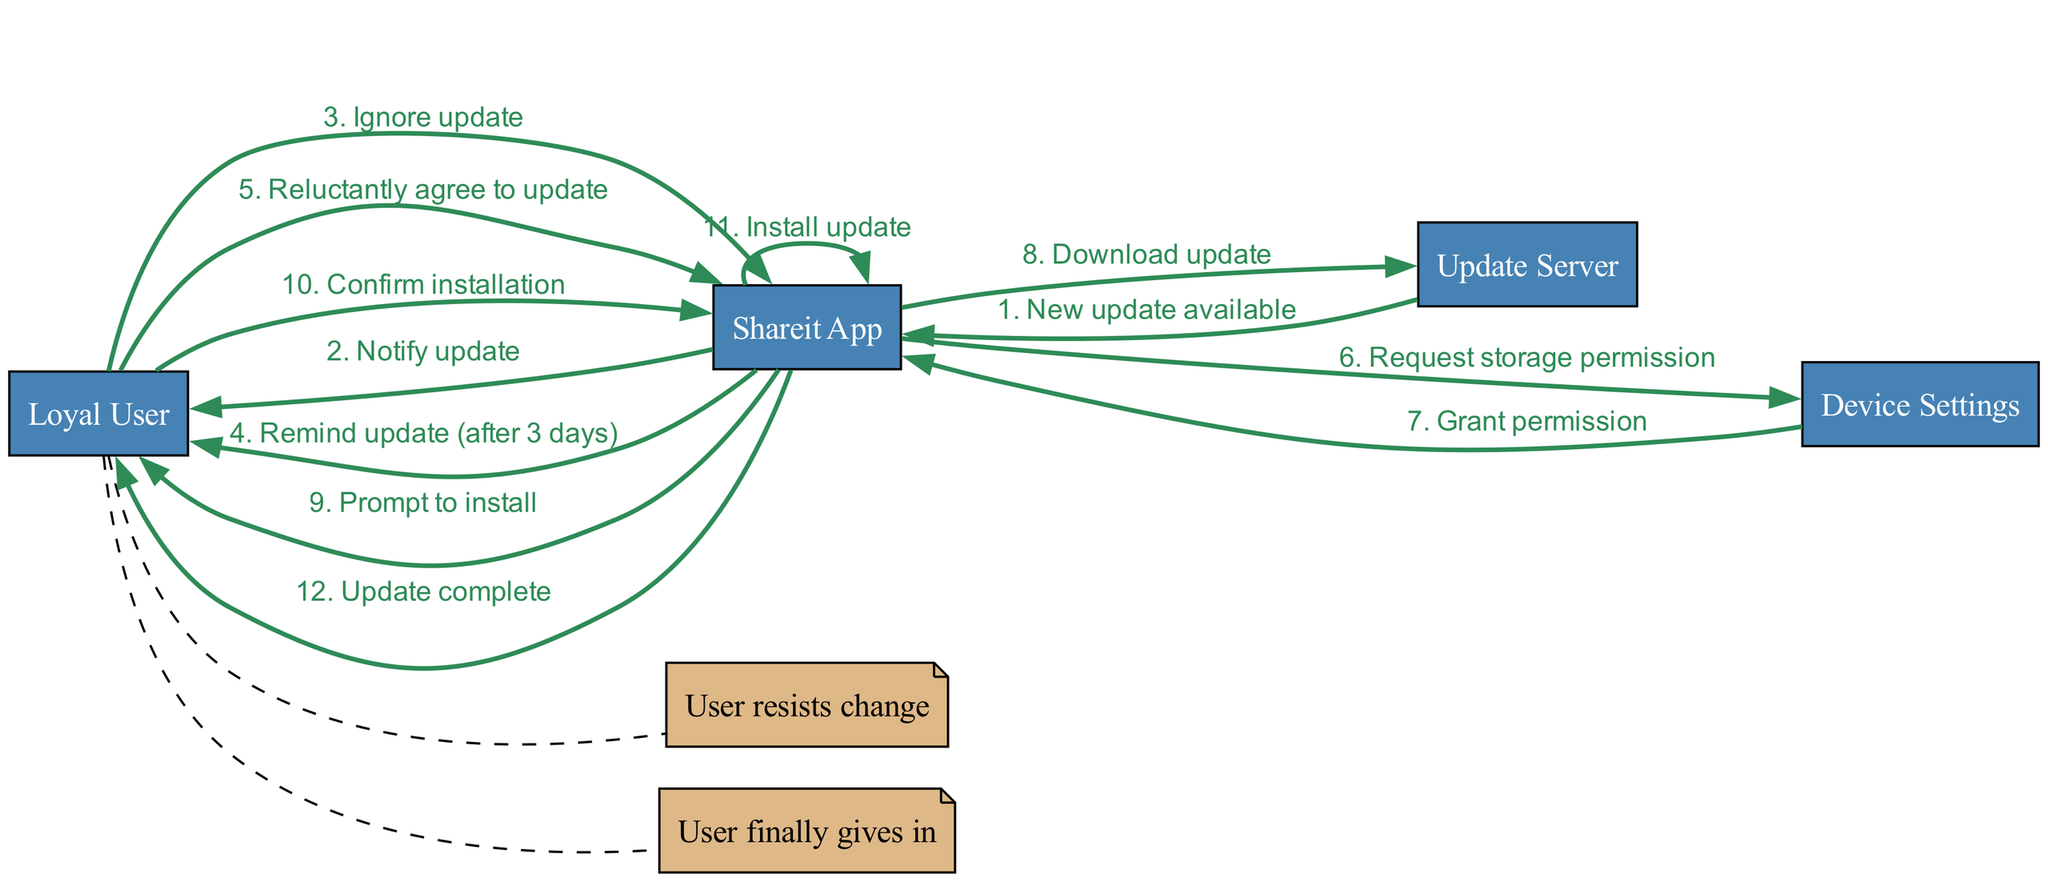What is the first message in the sequence? The first message sent from the Update Server to the Shareit App is "New update available". This can be found at the beginning of the sequence flow.
Answer: New update available How many actors are involved in this diagram? The diagram features four actors: Loyal User, Shareit App, Update Server, and Device Settings. By counting the listed actors, we find a total of four.
Answer: 4 What does the Shareit App prompt the Loyal User to do after downloading the update? After downloading the update, the Shareit App prompts the Loyal User to "Confirm installation". This message follows the download step in the sequence.
Answer: Prompt to install Which actor eventually grants permission to Shareit App? The Device Settings actor is the one that grants permission to Shareit App. This is shown after the Shareit App requests storage permission.
Answer: Device Settings What note is associated with the Loyal User's reluctance in the sequence? The note stating "User resists change" is linked with the scenario where the Loyal User ignores the update. This is highlighted after the user chooses to ignore the update.
Answer: User resists change What action follows the Loyal User confirming installation? After the Loyal User confirms installation, the Shareit App performs the action "Install update". This action occurs immediately after the confirmation message in the sequence.
Answer: Install update How many days after initial notification does the Shareit App remind the Loyal User? The Shareit App reminds the Loyal User after 3 days from the initial notification about the update. This specific timing is mentioned in the reminder message in the sequence.
Answer: 3 days What key event makes the Loyal User agree to update? The key event is the "Reluctantly agree to update" message from the Loyal User. This happens after a reminder is sent to them again.
Answer: Reluctantly agree to update 